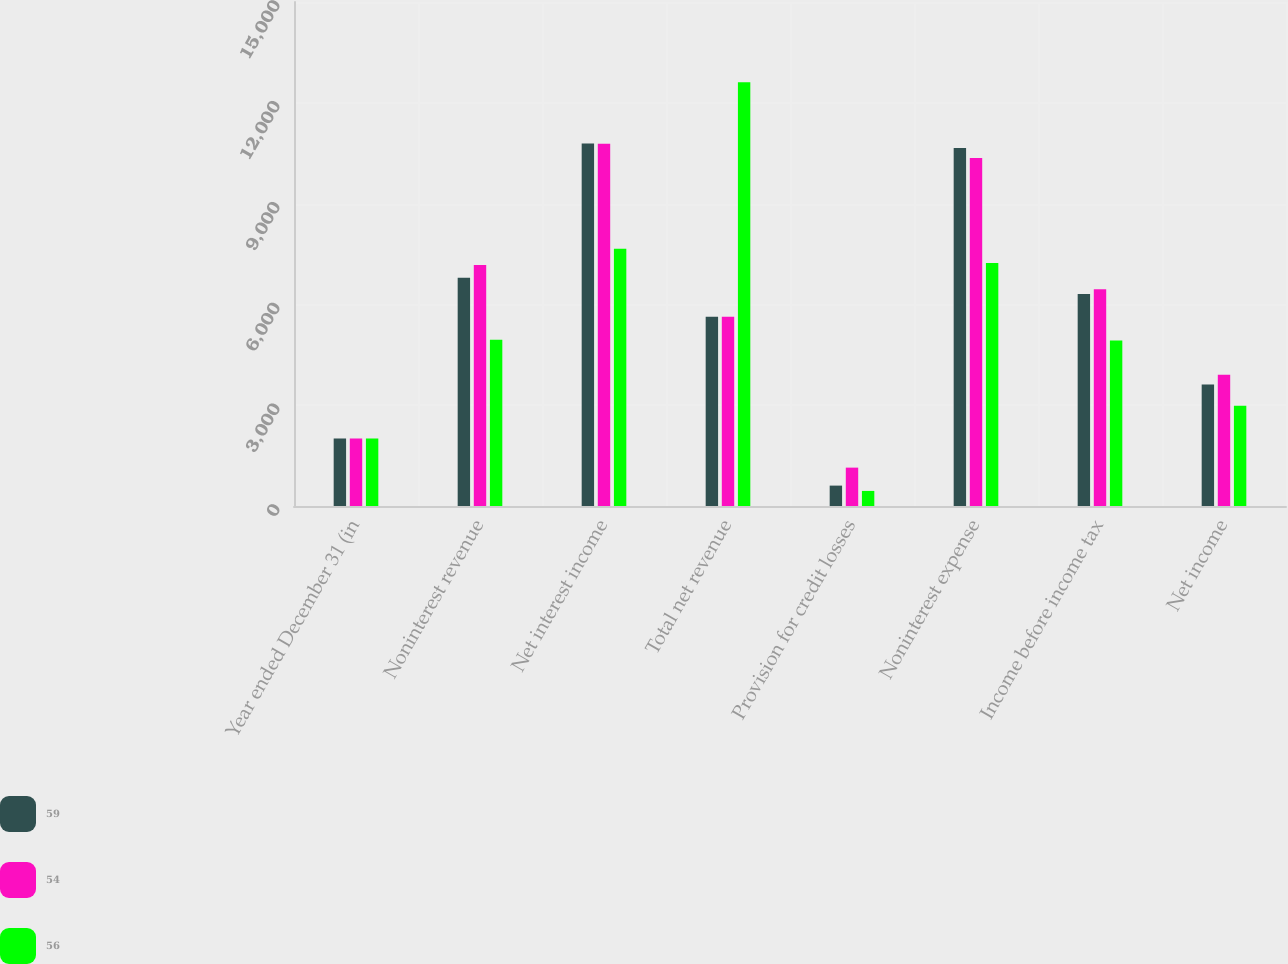Convert chart. <chart><loc_0><loc_0><loc_500><loc_500><stacked_bar_chart><ecel><fcel>Year ended December 31 (in<fcel>Noninterest revenue<fcel>Net interest income<fcel>Total net revenue<fcel>Provision for credit losses<fcel>Noninterest expense<fcel>Income before income tax<fcel>Net income<nl><fcel>59<fcel>2010<fcel>6792<fcel>10785<fcel>5632<fcel>607<fcel>10657<fcel>6313<fcel>3614<nl><fcel>54<fcel>2009<fcel>7169<fcel>10781<fcel>5632<fcel>1142<fcel>10357<fcel>6451<fcel>3903<nl><fcel>56<fcel>2008<fcel>4951<fcel>7659<fcel>12610<fcel>449<fcel>7232<fcel>4929<fcel>2982<nl></chart> 